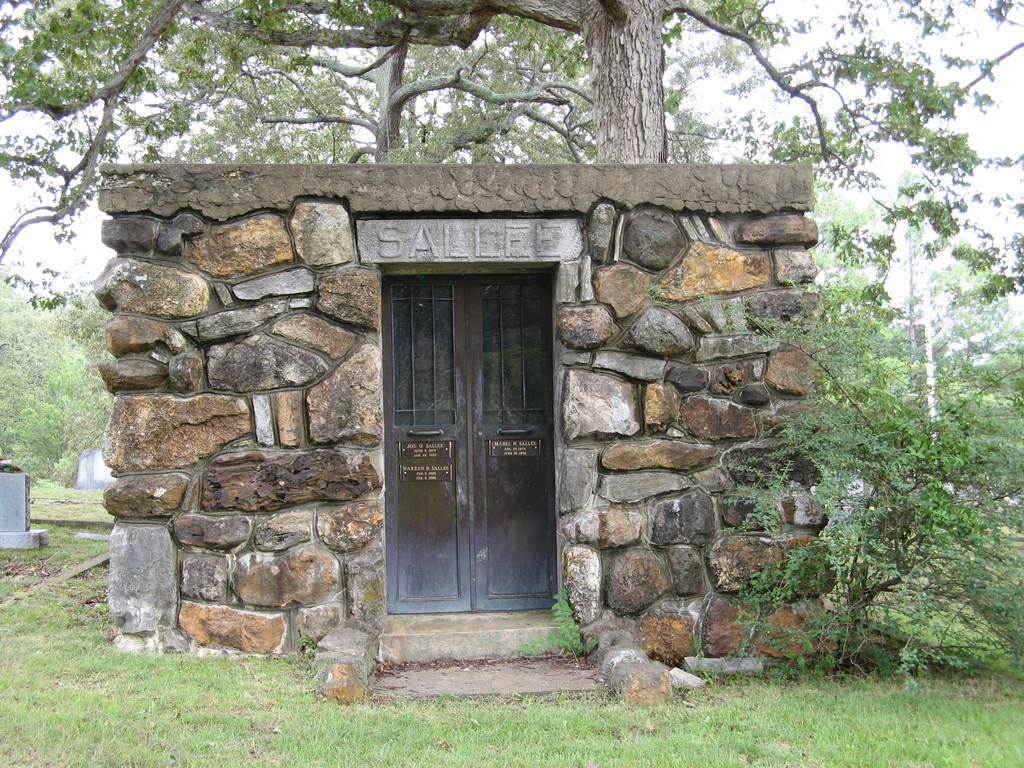What type of structure is present in the image? There is a house in the image. What feature of the house is visible? The house has a door. What type of vegetation is present in the image? There is grass and plants in the image. What part of a tree is visible in the image? The bark of a tree is visible in the image. How many trees are grouped together in the image? There is a group of trees in the image. What is visible in the background of the image? The sky is visible in the image. What is the condition of the sky in the image? The sky appears to be cloudy in the image. What type of frame is visible around the user in the image? There is no frame visible around the user in the image, as the image does not contain a user. 